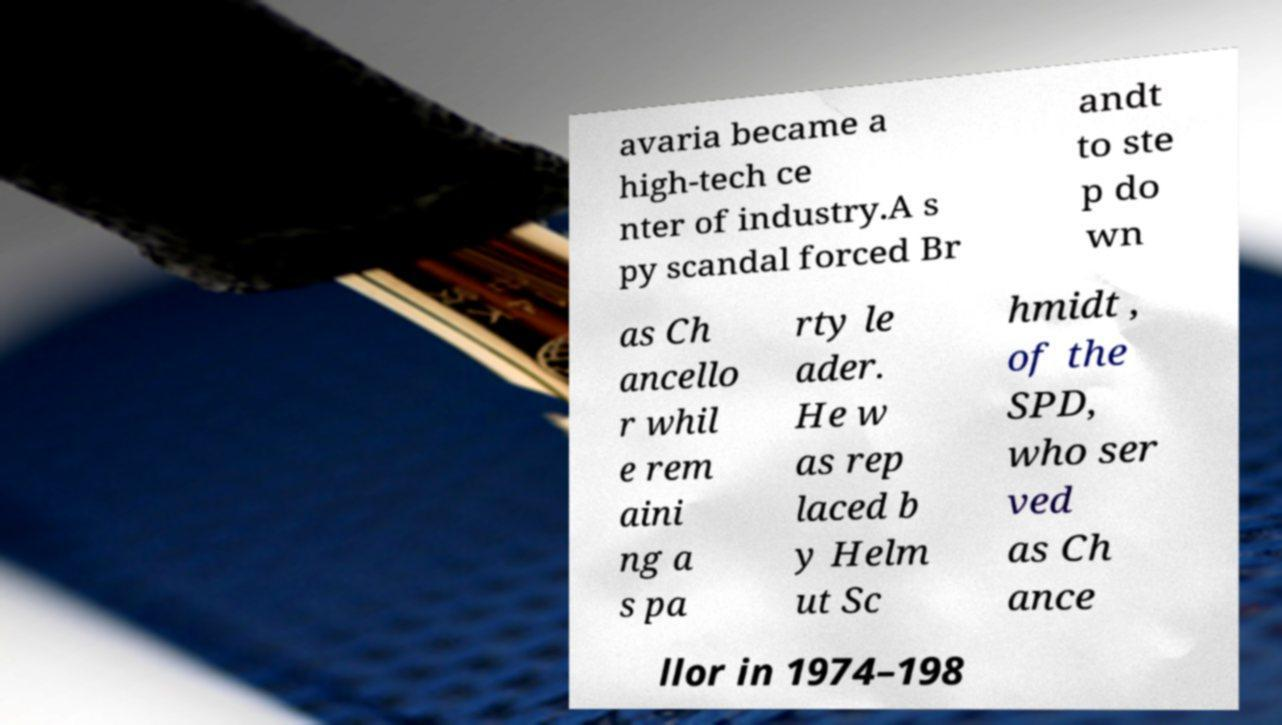There's text embedded in this image that I need extracted. Can you transcribe it verbatim? avaria became a high-tech ce nter of industry.A s py scandal forced Br andt to ste p do wn as Ch ancello r whil e rem aini ng a s pa rty le ader. He w as rep laced b y Helm ut Sc hmidt , of the SPD, who ser ved as Ch ance llor in 1974–198 